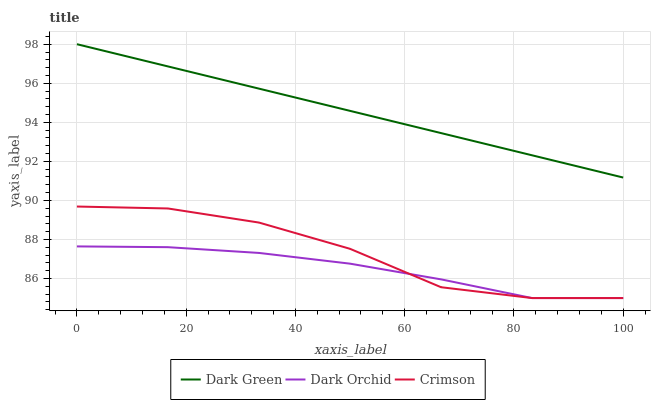Does Dark Orchid have the minimum area under the curve?
Answer yes or no. Yes. Does Dark Green have the maximum area under the curve?
Answer yes or no. Yes. Does Dark Green have the minimum area under the curve?
Answer yes or no. No. Does Dark Orchid have the maximum area under the curve?
Answer yes or no. No. Is Dark Green the smoothest?
Answer yes or no. Yes. Is Crimson the roughest?
Answer yes or no. Yes. Is Dark Orchid the smoothest?
Answer yes or no. No. Is Dark Orchid the roughest?
Answer yes or no. No. Does Crimson have the lowest value?
Answer yes or no. Yes. Does Dark Green have the lowest value?
Answer yes or no. No. Does Dark Green have the highest value?
Answer yes or no. Yes. Does Dark Orchid have the highest value?
Answer yes or no. No. Is Dark Orchid less than Dark Green?
Answer yes or no. Yes. Is Dark Green greater than Crimson?
Answer yes or no. Yes. Does Crimson intersect Dark Orchid?
Answer yes or no. Yes. Is Crimson less than Dark Orchid?
Answer yes or no. No. Is Crimson greater than Dark Orchid?
Answer yes or no. No. Does Dark Orchid intersect Dark Green?
Answer yes or no. No. 